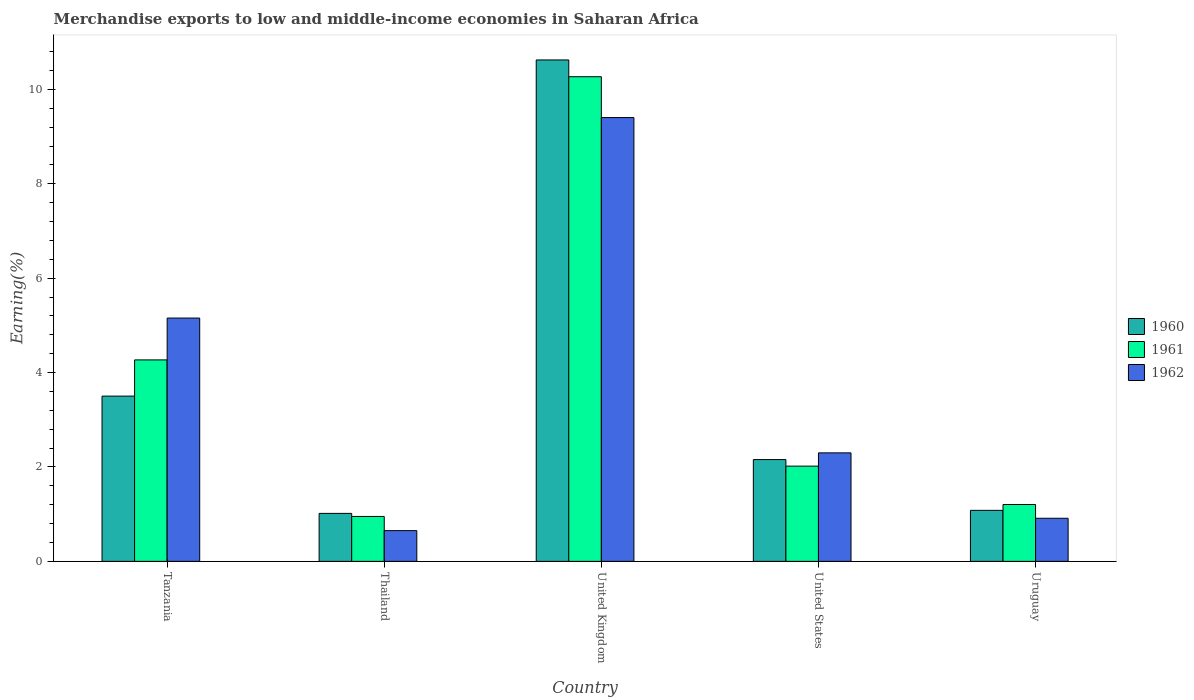Are the number of bars per tick equal to the number of legend labels?
Offer a very short reply. Yes. Are the number of bars on each tick of the X-axis equal?
Ensure brevity in your answer.  Yes. How many bars are there on the 4th tick from the left?
Your answer should be very brief. 3. What is the label of the 4th group of bars from the left?
Provide a succinct answer. United States. In how many cases, is the number of bars for a given country not equal to the number of legend labels?
Offer a very short reply. 0. What is the percentage of amount earned from merchandise exports in 1961 in United Kingdom?
Your answer should be compact. 10.27. Across all countries, what is the maximum percentage of amount earned from merchandise exports in 1962?
Ensure brevity in your answer.  9.4. Across all countries, what is the minimum percentage of amount earned from merchandise exports in 1961?
Give a very brief answer. 0.95. In which country was the percentage of amount earned from merchandise exports in 1960 minimum?
Offer a very short reply. Thailand. What is the total percentage of amount earned from merchandise exports in 1961 in the graph?
Provide a succinct answer. 18.71. What is the difference between the percentage of amount earned from merchandise exports in 1960 in Tanzania and that in United States?
Make the answer very short. 1.34. What is the difference between the percentage of amount earned from merchandise exports in 1962 in Thailand and the percentage of amount earned from merchandise exports in 1961 in Tanzania?
Provide a succinct answer. -3.62. What is the average percentage of amount earned from merchandise exports in 1962 per country?
Keep it short and to the point. 3.68. What is the difference between the percentage of amount earned from merchandise exports of/in 1960 and percentage of amount earned from merchandise exports of/in 1962 in Thailand?
Your answer should be compact. 0.37. In how many countries, is the percentage of amount earned from merchandise exports in 1961 greater than 9.6 %?
Ensure brevity in your answer.  1. What is the ratio of the percentage of amount earned from merchandise exports in 1960 in Thailand to that in United Kingdom?
Your answer should be very brief. 0.1. What is the difference between the highest and the second highest percentage of amount earned from merchandise exports in 1960?
Your answer should be compact. -8.47. What is the difference between the highest and the lowest percentage of amount earned from merchandise exports in 1960?
Your answer should be very brief. 9.61. In how many countries, is the percentage of amount earned from merchandise exports in 1962 greater than the average percentage of amount earned from merchandise exports in 1962 taken over all countries?
Offer a very short reply. 2. How many bars are there?
Offer a very short reply. 15. Are all the bars in the graph horizontal?
Provide a short and direct response. No. How many countries are there in the graph?
Provide a succinct answer. 5. What is the difference between two consecutive major ticks on the Y-axis?
Your response must be concise. 2. Are the values on the major ticks of Y-axis written in scientific E-notation?
Offer a very short reply. No. Does the graph contain any zero values?
Give a very brief answer. No. Does the graph contain grids?
Your response must be concise. No. Where does the legend appear in the graph?
Your response must be concise. Center right. How are the legend labels stacked?
Give a very brief answer. Vertical. What is the title of the graph?
Keep it short and to the point. Merchandise exports to low and middle-income economies in Saharan Africa. What is the label or title of the Y-axis?
Your answer should be very brief. Earning(%). What is the Earning(%) of 1960 in Tanzania?
Give a very brief answer. 3.5. What is the Earning(%) of 1961 in Tanzania?
Offer a terse response. 4.27. What is the Earning(%) of 1962 in Tanzania?
Keep it short and to the point. 5.16. What is the Earning(%) of 1960 in Thailand?
Your answer should be compact. 1.02. What is the Earning(%) of 1961 in Thailand?
Your answer should be compact. 0.95. What is the Earning(%) in 1962 in Thailand?
Make the answer very short. 0.65. What is the Earning(%) in 1960 in United Kingdom?
Provide a short and direct response. 10.63. What is the Earning(%) in 1961 in United Kingdom?
Provide a succinct answer. 10.27. What is the Earning(%) of 1962 in United Kingdom?
Give a very brief answer. 9.4. What is the Earning(%) in 1960 in United States?
Make the answer very short. 2.16. What is the Earning(%) in 1961 in United States?
Offer a terse response. 2.02. What is the Earning(%) of 1962 in United States?
Provide a short and direct response. 2.3. What is the Earning(%) of 1960 in Uruguay?
Offer a very short reply. 1.08. What is the Earning(%) in 1961 in Uruguay?
Give a very brief answer. 1.2. What is the Earning(%) of 1962 in Uruguay?
Offer a very short reply. 0.91. Across all countries, what is the maximum Earning(%) in 1960?
Keep it short and to the point. 10.63. Across all countries, what is the maximum Earning(%) of 1961?
Your answer should be very brief. 10.27. Across all countries, what is the maximum Earning(%) of 1962?
Keep it short and to the point. 9.4. Across all countries, what is the minimum Earning(%) of 1960?
Your response must be concise. 1.02. Across all countries, what is the minimum Earning(%) in 1961?
Your answer should be very brief. 0.95. Across all countries, what is the minimum Earning(%) of 1962?
Offer a terse response. 0.65. What is the total Earning(%) of 1960 in the graph?
Keep it short and to the point. 18.38. What is the total Earning(%) in 1961 in the graph?
Keep it short and to the point. 18.71. What is the total Earning(%) in 1962 in the graph?
Provide a succinct answer. 18.42. What is the difference between the Earning(%) of 1960 in Tanzania and that in Thailand?
Ensure brevity in your answer.  2.49. What is the difference between the Earning(%) in 1961 in Tanzania and that in Thailand?
Your response must be concise. 3.32. What is the difference between the Earning(%) in 1962 in Tanzania and that in Thailand?
Offer a terse response. 4.5. What is the difference between the Earning(%) of 1960 in Tanzania and that in United Kingdom?
Your response must be concise. -7.12. What is the difference between the Earning(%) of 1961 in Tanzania and that in United Kingdom?
Give a very brief answer. -6. What is the difference between the Earning(%) of 1962 in Tanzania and that in United Kingdom?
Your answer should be very brief. -4.25. What is the difference between the Earning(%) in 1960 in Tanzania and that in United States?
Your response must be concise. 1.34. What is the difference between the Earning(%) in 1961 in Tanzania and that in United States?
Provide a short and direct response. 2.25. What is the difference between the Earning(%) of 1962 in Tanzania and that in United States?
Ensure brevity in your answer.  2.86. What is the difference between the Earning(%) in 1960 in Tanzania and that in Uruguay?
Your answer should be very brief. 2.42. What is the difference between the Earning(%) in 1961 in Tanzania and that in Uruguay?
Offer a terse response. 3.06. What is the difference between the Earning(%) in 1962 in Tanzania and that in Uruguay?
Your answer should be very brief. 4.24. What is the difference between the Earning(%) of 1960 in Thailand and that in United Kingdom?
Keep it short and to the point. -9.61. What is the difference between the Earning(%) of 1961 in Thailand and that in United Kingdom?
Keep it short and to the point. -9.32. What is the difference between the Earning(%) in 1962 in Thailand and that in United Kingdom?
Make the answer very short. -8.75. What is the difference between the Earning(%) in 1960 in Thailand and that in United States?
Provide a succinct answer. -1.14. What is the difference between the Earning(%) in 1961 in Thailand and that in United States?
Offer a terse response. -1.07. What is the difference between the Earning(%) of 1962 in Thailand and that in United States?
Make the answer very short. -1.65. What is the difference between the Earning(%) of 1960 in Thailand and that in Uruguay?
Your response must be concise. -0.06. What is the difference between the Earning(%) of 1961 in Thailand and that in Uruguay?
Your answer should be compact. -0.25. What is the difference between the Earning(%) of 1962 in Thailand and that in Uruguay?
Offer a terse response. -0.26. What is the difference between the Earning(%) of 1960 in United Kingdom and that in United States?
Offer a very short reply. 8.47. What is the difference between the Earning(%) in 1961 in United Kingdom and that in United States?
Make the answer very short. 8.25. What is the difference between the Earning(%) of 1962 in United Kingdom and that in United States?
Give a very brief answer. 7.11. What is the difference between the Earning(%) in 1960 in United Kingdom and that in Uruguay?
Make the answer very short. 9.54. What is the difference between the Earning(%) in 1961 in United Kingdom and that in Uruguay?
Your response must be concise. 9.07. What is the difference between the Earning(%) of 1962 in United Kingdom and that in Uruguay?
Provide a succinct answer. 8.49. What is the difference between the Earning(%) in 1960 in United States and that in Uruguay?
Your response must be concise. 1.08. What is the difference between the Earning(%) of 1961 in United States and that in Uruguay?
Your answer should be very brief. 0.81. What is the difference between the Earning(%) of 1962 in United States and that in Uruguay?
Offer a very short reply. 1.39. What is the difference between the Earning(%) in 1960 in Tanzania and the Earning(%) in 1961 in Thailand?
Provide a short and direct response. 2.55. What is the difference between the Earning(%) in 1960 in Tanzania and the Earning(%) in 1962 in Thailand?
Make the answer very short. 2.85. What is the difference between the Earning(%) of 1961 in Tanzania and the Earning(%) of 1962 in Thailand?
Your response must be concise. 3.62. What is the difference between the Earning(%) in 1960 in Tanzania and the Earning(%) in 1961 in United Kingdom?
Provide a succinct answer. -6.77. What is the difference between the Earning(%) of 1960 in Tanzania and the Earning(%) of 1962 in United Kingdom?
Give a very brief answer. -5.9. What is the difference between the Earning(%) of 1961 in Tanzania and the Earning(%) of 1962 in United Kingdom?
Give a very brief answer. -5.14. What is the difference between the Earning(%) in 1960 in Tanzania and the Earning(%) in 1961 in United States?
Provide a succinct answer. 1.48. What is the difference between the Earning(%) of 1960 in Tanzania and the Earning(%) of 1962 in United States?
Offer a very short reply. 1.2. What is the difference between the Earning(%) of 1961 in Tanzania and the Earning(%) of 1962 in United States?
Your response must be concise. 1.97. What is the difference between the Earning(%) of 1960 in Tanzania and the Earning(%) of 1961 in Uruguay?
Provide a succinct answer. 2.3. What is the difference between the Earning(%) in 1960 in Tanzania and the Earning(%) in 1962 in Uruguay?
Your answer should be very brief. 2.59. What is the difference between the Earning(%) of 1961 in Tanzania and the Earning(%) of 1962 in Uruguay?
Provide a short and direct response. 3.36. What is the difference between the Earning(%) of 1960 in Thailand and the Earning(%) of 1961 in United Kingdom?
Provide a succinct answer. -9.25. What is the difference between the Earning(%) of 1960 in Thailand and the Earning(%) of 1962 in United Kingdom?
Your answer should be compact. -8.39. What is the difference between the Earning(%) of 1961 in Thailand and the Earning(%) of 1962 in United Kingdom?
Your answer should be compact. -8.45. What is the difference between the Earning(%) in 1960 in Thailand and the Earning(%) in 1961 in United States?
Provide a short and direct response. -1. What is the difference between the Earning(%) in 1960 in Thailand and the Earning(%) in 1962 in United States?
Keep it short and to the point. -1.28. What is the difference between the Earning(%) in 1961 in Thailand and the Earning(%) in 1962 in United States?
Give a very brief answer. -1.35. What is the difference between the Earning(%) in 1960 in Thailand and the Earning(%) in 1961 in Uruguay?
Your answer should be compact. -0.19. What is the difference between the Earning(%) in 1960 in Thailand and the Earning(%) in 1962 in Uruguay?
Offer a terse response. 0.1. What is the difference between the Earning(%) in 1961 in Thailand and the Earning(%) in 1962 in Uruguay?
Give a very brief answer. 0.04. What is the difference between the Earning(%) in 1960 in United Kingdom and the Earning(%) in 1961 in United States?
Give a very brief answer. 8.61. What is the difference between the Earning(%) of 1960 in United Kingdom and the Earning(%) of 1962 in United States?
Provide a short and direct response. 8.33. What is the difference between the Earning(%) of 1961 in United Kingdom and the Earning(%) of 1962 in United States?
Provide a short and direct response. 7.97. What is the difference between the Earning(%) of 1960 in United Kingdom and the Earning(%) of 1961 in Uruguay?
Offer a very short reply. 9.42. What is the difference between the Earning(%) in 1960 in United Kingdom and the Earning(%) in 1962 in Uruguay?
Your answer should be very brief. 9.71. What is the difference between the Earning(%) in 1961 in United Kingdom and the Earning(%) in 1962 in Uruguay?
Offer a very short reply. 9.36. What is the difference between the Earning(%) of 1960 in United States and the Earning(%) of 1961 in Uruguay?
Provide a succinct answer. 0.95. What is the difference between the Earning(%) in 1960 in United States and the Earning(%) in 1962 in Uruguay?
Provide a succinct answer. 1.24. What is the difference between the Earning(%) of 1961 in United States and the Earning(%) of 1962 in Uruguay?
Provide a short and direct response. 1.1. What is the average Earning(%) of 1960 per country?
Ensure brevity in your answer.  3.68. What is the average Earning(%) in 1961 per country?
Your answer should be very brief. 3.74. What is the average Earning(%) of 1962 per country?
Keep it short and to the point. 3.68. What is the difference between the Earning(%) in 1960 and Earning(%) in 1961 in Tanzania?
Give a very brief answer. -0.77. What is the difference between the Earning(%) of 1960 and Earning(%) of 1962 in Tanzania?
Keep it short and to the point. -1.65. What is the difference between the Earning(%) in 1961 and Earning(%) in 1962 in Tanzania?
Provide a succinct answer. -0.89. What is the difference between the Earning(%) of 1960 and Earning(%) of 1961 in Thailand?
Your answer should be very brief. 0.06. What is the difference between the Earning(%) in 1960 and Earning(%) in 1962 in Thailand?
Ensure brevity in your answer.  0.37. What is the difference between the Earning(%) of 1961 and Earning(%) of 1962 in Thailand?
Your response must be concise. 0.3. What is the difference between the Earning(%) of 1960 and Earning(%) of 1961 in United Kingdom?
Your response must be concise. 0.36. What is the difference between the Earning(%) of 1960 and Earning(%) of 1962 in United Kingdom?
Your answer should be compact. 1.22. What is the difference between the Earning(%) of 1961 and Earning(%) of 1962 in United Kingdom?
Ensure brevity in your answer.  0.87. What is the difference between the Earning(%) of 1960 and Earning(%) of 1961 in United States?
Your response must be concise. 0.14. What is the difference between the Earning(%) in 1960 and Earning(%) in 1962 in United States?
Give a very brief answer. -0.14. What is the difference between the Earning(%) of 1961 and Earning(%) of 1962 in United States?
Your response must be concise. -0.28. What is the difference between the Earning(%) in 1960 and Earning(%) in 1961 in Uruguay?
Ensure brevity in your answer.  -0.12. What is the difference between the Earning(%) in 1960 and Earning(%) in 1962 in Uruguay?
Give a very brief answer. 0.17. What is the difference between the Earning(%) in 1961 and Earning(%) in 1962 in Uruguay?
Give a very brief answer. 0.29. What is the ratio of the Earning(%) in 1960 in Tanzania to that in Thailand?
Ensure brevity in your answer.  3.44. What is the ratio of the Earning(%) of 1961 in Tanzania to that in Thailand?
Your answer should be compact. 4.48. What is the ratio of the Earning(%) in 1962 in Tanzania to that in Thailand?
Offer a very short reply. 7.92. What is the ratio of the Earning(%) in 1960 in Tanzania to that in United Kingdom?
Provide a succinct answer. 0.33. What is the ratio of the Earning(%) in 1961 in Tanzania to that in United Kingdom?
Your answer should be very brief. 0.42. What is the ratio of the Earning(%) of 1962 in Tanzania to that in United Kingdom?
Keep it short and to the point. 0.55. What is the ratio of the Earning(%) of 1960 in Tanzania to that in United States?
Offer a very short reply. 1.62. What is the ratio of the Earning(%) of 1961 in Tanzania to that in United States?
Make the answer very short. 2.12. What is the ratio of the Earning(%) of 1962 in Tanzania to that in United States?
Your answer should be very brief. 2.24. What is the ratio of the Earning(%) of 1960 in Tanzania to that in Uruguay?
Make the answer very short. 3.24. What is the ratio of the Earning(%) of 1961 in Tanzania to that in Uruguay?
Your response must be concise. 3.54. What is the ratio of the Earning(%) of 1962 in Tanzania to that in Uruguay?
Provide a short and direct response. 5.65. What is the ratio of the Earning(%) of 1960 in Thailand to that in United Kingdom?
Offer a very short reply. 0.1. What is the ratio of the Earning(%) of 1961 in Thailand to that in United Kingdom?
Offer a terse response. 0.09. What is the ratio of the Earning(%) of 1962 in Thailand to that in United Kingdom?
Give a very brief answer. 0.07. What is the ratio of the Earning(%) of 1960 in Thailand to that in United States?
Your response must be concise. 0.47. What is the ratio of the Earning(%) in 1961 in Thailand to that in United States?
Provide a succinct answer. 0.47. What is the ratio of the Earning(%) of 1962 in Thailand to that in United States?
Give a very brief answer. 0.28. What is the ratio of the Earning(%) in 1960 in Thailand to that in Uruguay?
Provide a short and direct response. 0.94. What is the ratio of the Earning(%) of 1961 in Thailand to that in Uruguay?
Keep it short and to the point. 0.79. What is the ratio of the Earning(%) in 1962 in Thailand to that in Uruguay?
Provide a succinct answer. 0.71. What is the ratio of the Earning(%) of 1960 in United Kingdom to that in United States?
Give a very brief answer. 4.93. What is the ratio of the Earning(%) of 1961 in United Kingdom to that in United States?
Your response must be concise. 5.09. What is the ratio of the Earning(%) in 1962 in United Kingdom to that in United States?
Your response must be concise. 4.09. What is the ratio of the Earning(%) of 1960 in United Kingdom to that in Uruguay?
Ensure brevity in your answer.  9.83. What is the ratio of the Earning(%) of 1961 in United Kingdom to that in Uruguay?
Keep it short and to the point. 8.52. What is the ratio of the Earning(%) of 1962 in United Kingdom to that in Uruguay?
Provide a short and direct response. 10.3. What is the ratio of the Earning(%) of 1960 in United States to that in Uruguay?
Your answer should be compact. 2. What is the ratio of the Earning(%) in 1961 in United States to that in Uruguay?
Make the answer very short. 1.68. What is the ratio of the Earning(%) in 1962 in United States to that in Uruguay?
Offer a very short reply. 2.52. What is the difference between the highest and the second highest Earning(%) of 1960?
Your answer should be compact. 7.12. What is the difference between the highest and the second highest Earning(%) of 1961?
Keep it short and to the point. 6. What is the difference between the highest and the second highest Earning(%) in 1962?
Provide a succinct answer. 4.25. What is the difference between the highest and the lowest Earning(%) in 1960?
Your answer should be very brief. 9.61. What is the difference between the highest and the lowest Earning(%) in 1961?
Offer a terse response. 9.32. What is the difference between the highest and the lowest Earning(%) of 1962?
Provide a short and direct response. 8.75. 